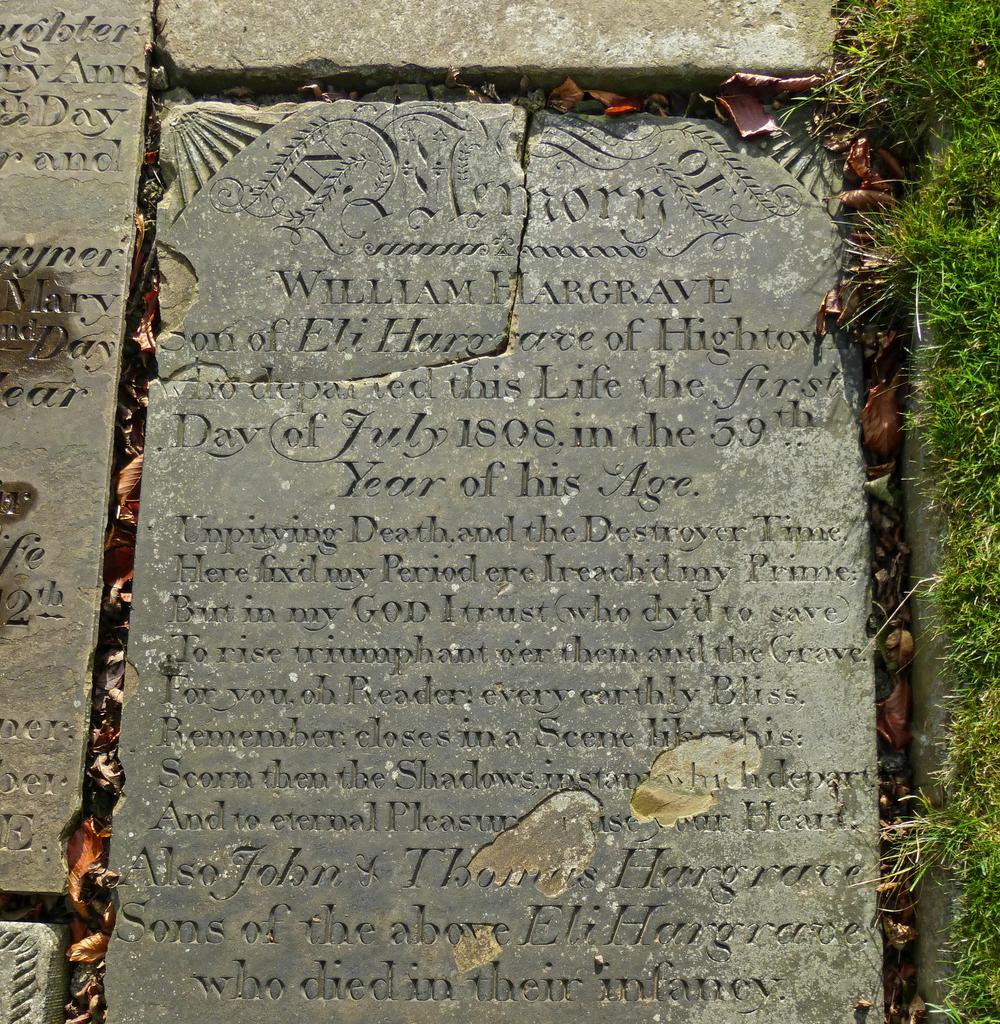What object can be seen in the image that is related to an inauguration? There is an inauguration plate in the image. What type of natural environment is visible in the image? There is grass visible in the image. What type of creature is made of copper and brass in the image? There is no creature made of copper and brass present in the image. 